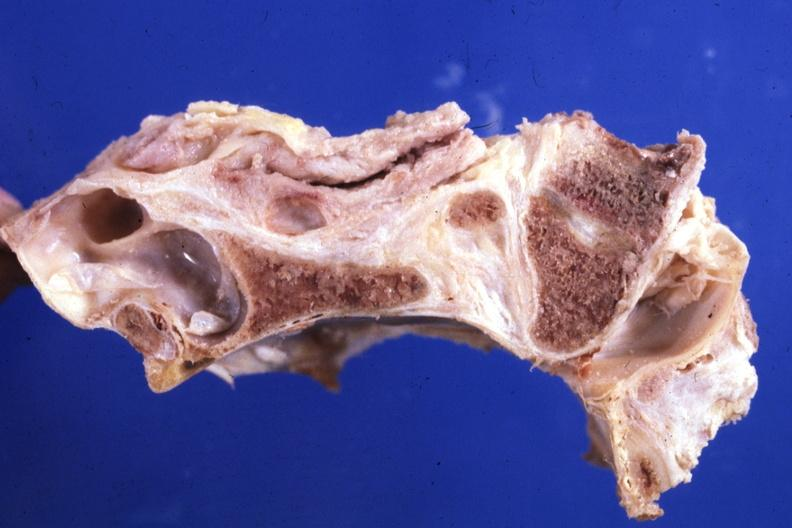s bone, calvarium present?
Answer the question using a single word or phrase. Yes 